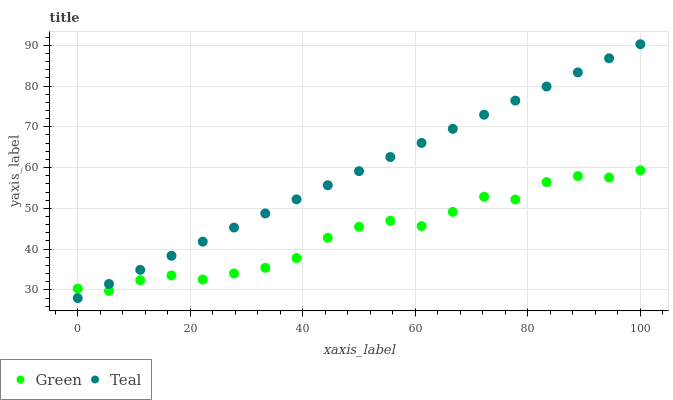Does Green have the minimum area under the curve?
Answer yes or no. Yes. Does Teal have the maximum area under the curve?
Answer yes or no. Yes. Does Teal have the minimum area under the curve?
Answer yes or no. No. Is Teal the smoothest?
Answer yes or no. Yes. Is Green the roughest?
Answer yes or no. Yes. Is Teal the roughest?
Answer yes or no. No. Does Teal have the lowest value?
Answer yes or no. Yes. Does Teal have the highest value?
Answer yes or no. Yes. Does Green intersect Teal?
Answer yes or no. Yes. Is Green less than Teal?
Answer yes or no. No. Is Green greater than Teal?
Answer yes or no. No. 